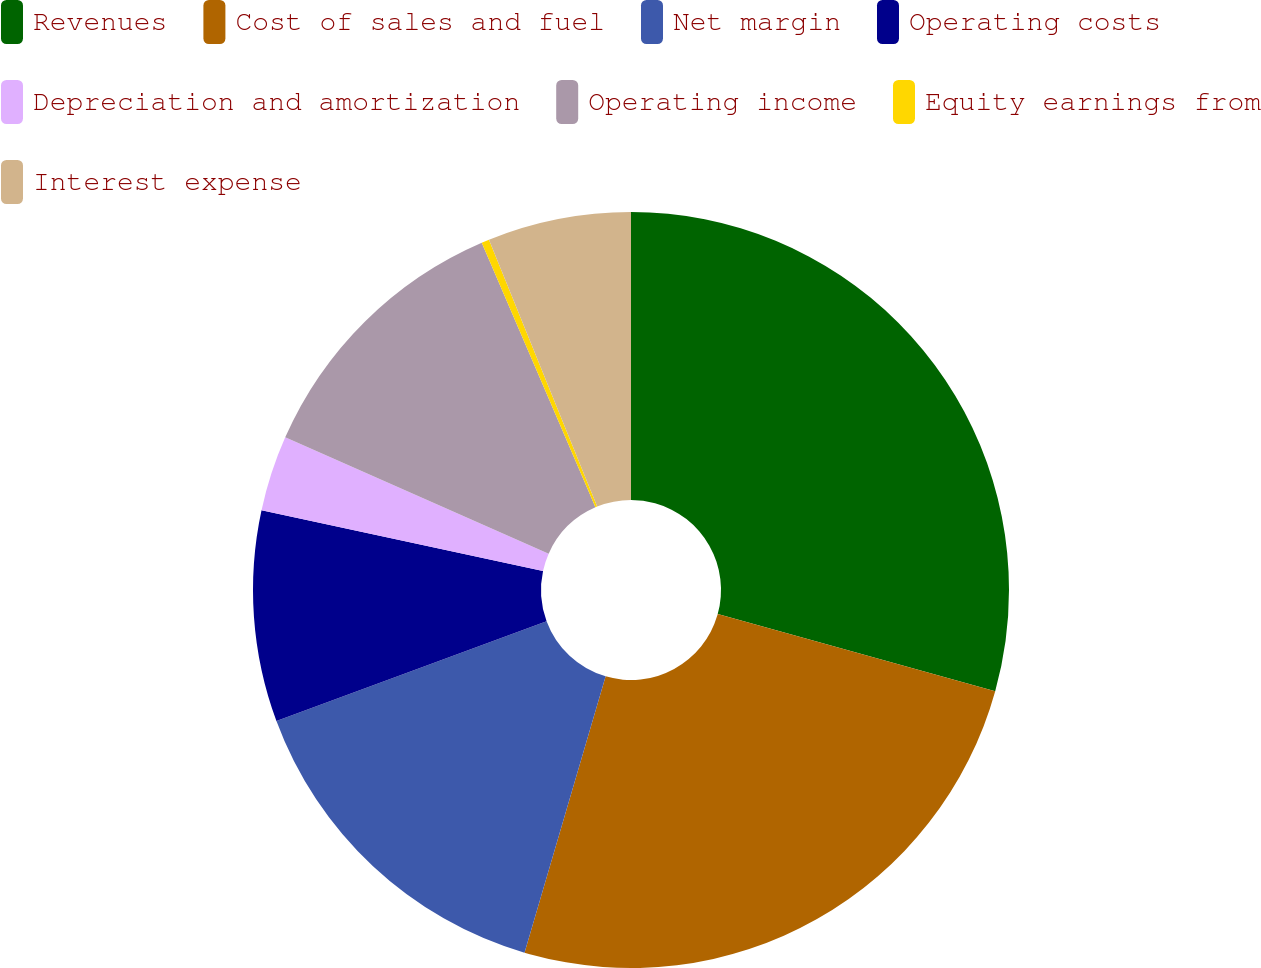Convert chart to OTSL. <chart><loc_0><loc_0><loc_500><loc_500><pie_chart><fcel>Revenues<fcel>Cost of sales and fuel<fcel>Net margin<fcel>Operating costs<fcel>Depreciation and amortization<fcel>Operating income<fcel>Equity earnings from<fcel>Interest expense<nl><fcel>29.31%<fcel>25.23%<fcel>14.82%<fcel>9.02%<fcel>3.23%<fcel>11.92%<fcel>0.33%<fcel>6.13%<nl></chart> 